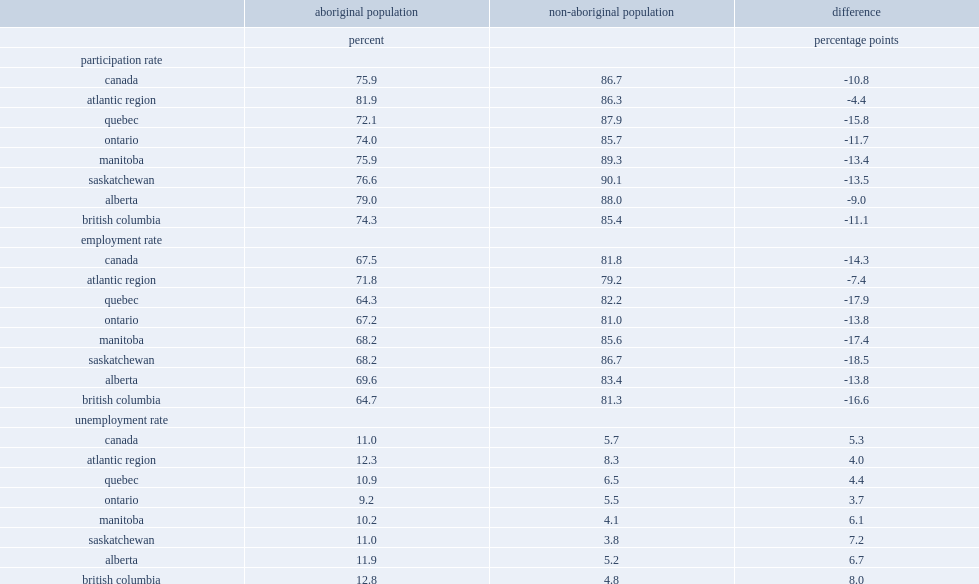In 2015, what was the employment rate for aboriginal people which was highest in the atlantic region? 71.8. In 2015, what was the employment rate for non-aboriginal people which was highest in the atlantic region at 79.2%? 79.2. What was the smallest disparity of the atlantic region had in employment rates between aboriginal and non-aboriginal people observed among the provinces/regions? 7.4. 